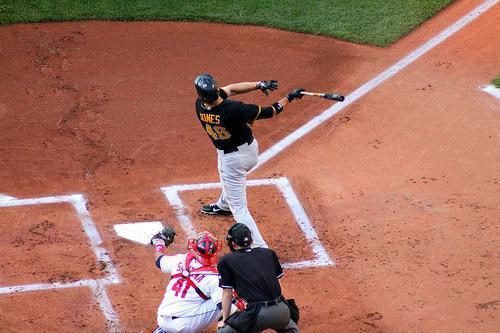How many people in photo?
Give a very brief answer. 3. 